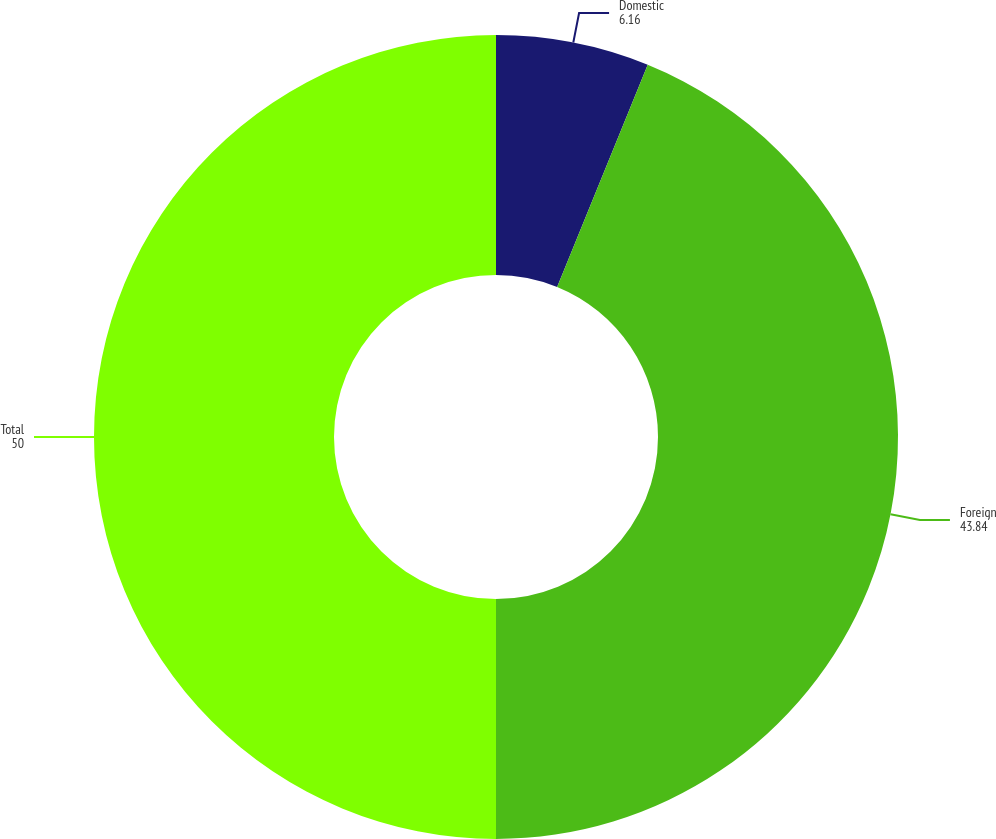Convert chart. <chart><loc_0><loc_0><loc_500><loc_500><pie_chart><fcel>Domestic<fcel>Foreign<fcel>Total<nl><fcel>6.16%<fcel>43.84%<fcel>50.0%<nl></chart> 